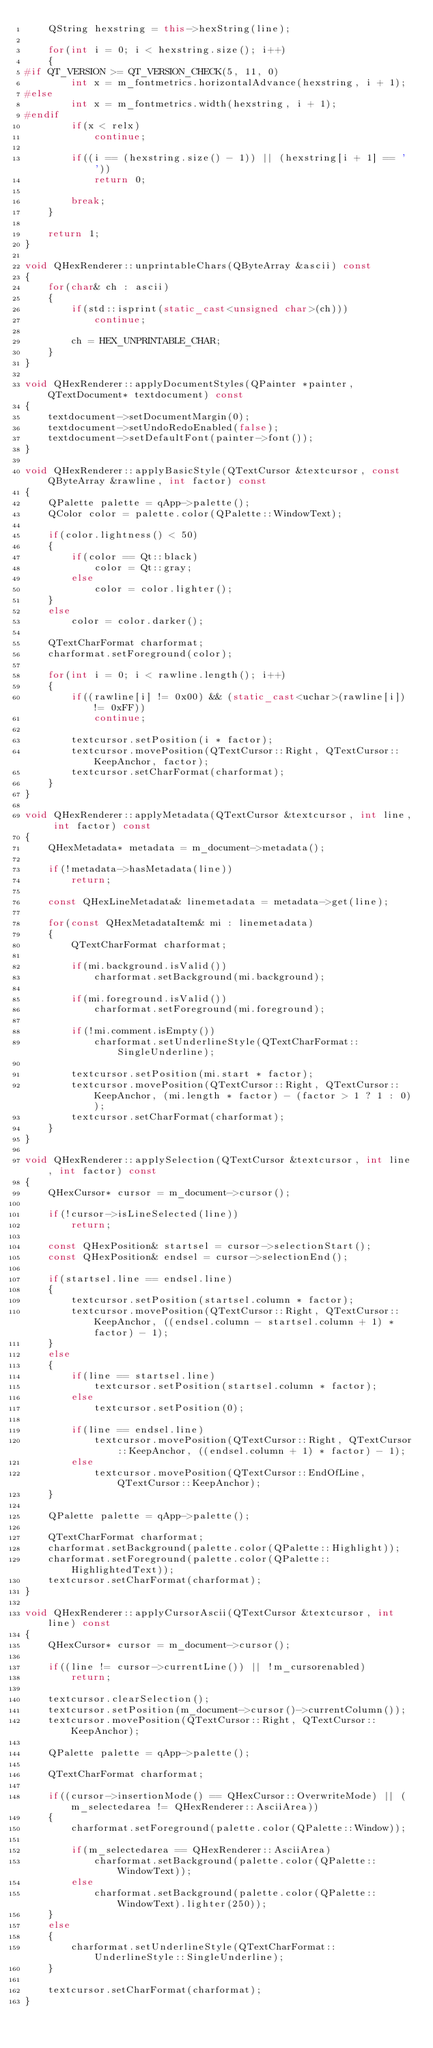Convert code to text. <code><loc_0><loc_0><loc_500><loc_500><_C++_>    QString hexstring = this->hexString(line);

    for(int i = 0; i < hexstring.size(); i++)
    {
#if QT_VERSION >= QT_VERSION_CHECK(5, 11, 0)
        int x = m_fontmetrics.horizontalAdvance(hexstring, i + 1);
#else
        int x = m_fontmetrics.width(hexstring, i + 1);
#endif
        if(x < relx)
            continue;

        if((i == (hexstring.size() - 1)) || (hexstring[i + 1] == ' '))
            return 0;

        break;
    }

    return 1;
}

void QHexRenderer::unprintableChars(QByteArray &ascii) const
{
    for(char& ch : ascii)
    {
        if(std::isprint(static_cast<unsigned char>(ch)))
            continue;

        ch = HEX_UNPRINTABLE_CHAR;
    }
}

void QHexRenderer::applyDocumentStyles(QPainter *painter, QTextDocument* textdocument) const
{
    textdocument->setDocumentMargin(0);
    textdocument->setUndoRedoEnabled(false);
    textdocument->setDefaultFont(painter->font());
}

void QHexRenderer::applyBasicStyle(QTextCursor &textcursor, const QByteArray &rawline, int factor) const
{
    QPalette palette = qApp->palette();
    QColor color = palette.color(QPalette::WindowText);

    if(color.lightness() < 50)
    {
        if(color == Qt::black)
            color = Qt::gray;
        else
            color = color.lighter();
    }
    else
        color = color.darker();

    QTextCharFormat charformat;
    charformat.setForeground(color);

    for(int i = 0; i < rawline.length(); i++)
    {
        if((rawline[i] != 0x00) && (static_cast<uchar>(rawline[i]) != 0xFF))
            continue;

        textcursor.setPosition(i * factor);
        textcursor.movePosition(QTextCursor::Right, QTextCursor::KeepAnchor, factor);
        textcursor.setCharFormat(charformat);
    }
}

void QHexRenderer::applyMetadata(QTextCursor &textcursor, int line, int factor) const
{
    QHexMetadata* metadata = m_document->metadata();

    if(!metadata->hasMetadata(line))
        return;

    const QHexLineMetadata& linemetadata = metadata->get(line);

    for(const QHexMetadataItem& mi : linemetadata)
    {
        QTextCharFormat charformat;

        if(mi.background.isValid())
            charformat.setBackground(mi.background);

        if(mi.foreground.isValid())
            charformat.setForeground(mi.foreground);

        if(!mi.comment.isEmpty())
            charformat.setUnderlineStyle(QTextCharFormat::SingleUnderline);

        textcursor.setPosition(mi.start * factor);
        textcursor.movePosition(QTextCursor::Right, QTextCursor::KeepAnchor, (mi.length * factor) - (factor > 1 ? 1 : 0));
        textcursor.setCharFormat(charformat);
    }
}

void QHexRenderer::applySelection(QTextCursor &textcursor, int line, int factor) const
{
    QHexCursor* cursor = m_document->cursor();

    if(!cursor->isLineSelected(line))
        return;

    const QHexPosition& startsel = cursor->selectionStart();
    const QHexPosition& endsel = cursor->selectionEnd();

    if(startsel.line == endsel.line)
    {
        textcursor.setPosition(startsel.column * factor);
        textcursor.movePosition(QTextCursor::Right, QTextCursor::KeepAnchor, ((endsel.column - startsel.column + 1) * factor) - 1);
    }
    else
    {
        if(line == startsel.line)
            textcursor.setPosition(startsel.column * factor);
        else
            textcursor.setPosition(0);

        if(line == endsel.line)
            textcursor.movePosition(QTextCursor::Right, QTextCursor::KeepAnchor, ((endsel.column + 1) * factor) - 1);
        else
            textcursor.movePosition(QTextCursor::EndOfLine, QTextCursor::KeepAnchor);
    }

    QPalette palette = qApp->palette();

    QTextCharFormat charformat;
    charformat.setBackground(palette.color(QPalette::Highlight));
    charformat.setForeground(palette.color(QPalette::HighlightedText));
    textcursor.setCharFormat(charformat);
}

void QHexRenderer::applyCursorAscii(QTextCursor &textcursor, int line) const
{
    QHexCursor* cursor = m_document->cursor();

    if((line != cursor->currentLine()) || !m_cursorenabled)
        return;

    textcursor.clearSelection();
    textcursor.setPosition(m_document->cursor()->currentColumn());
    textcursor.movePosition(QTextCursor::Right, QTextCursor::KeepAnchor);

    QPalette palette = qApp->palette();

    QTextCharFormat charformat;

    if((cursor->insertionMode() == QHexCursor::OverwriteMode) || (m_selectedarea != QHexRenderer::AsciiArea))
    {
        charformat.setForeground(palette.color(QPalette::Window));

        if(m_selectedarea == QHexRenderer::AsciiArea)
            charformat.setBackground(palette.color(QPalette::WindowText));
        else
            charformat.setBackground(palette.color(QPalette::WindowText).lighter(250));
    }
    else
    {
        charformat.setUnderlineStyle(QTextCharFormat::UnderlineStyle::SingleUnderline);
    }

    textcursor.setCharFormat(charformat);
}
</code> 